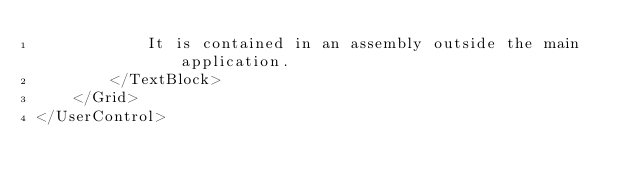Convert code to text. <code><loc_0><loc_0><loc_500><loc_500><_XML_>            It is contained in an assembly outside the main application.
        </TextBlock>
    </Grid>
</UserControl>
</code> 